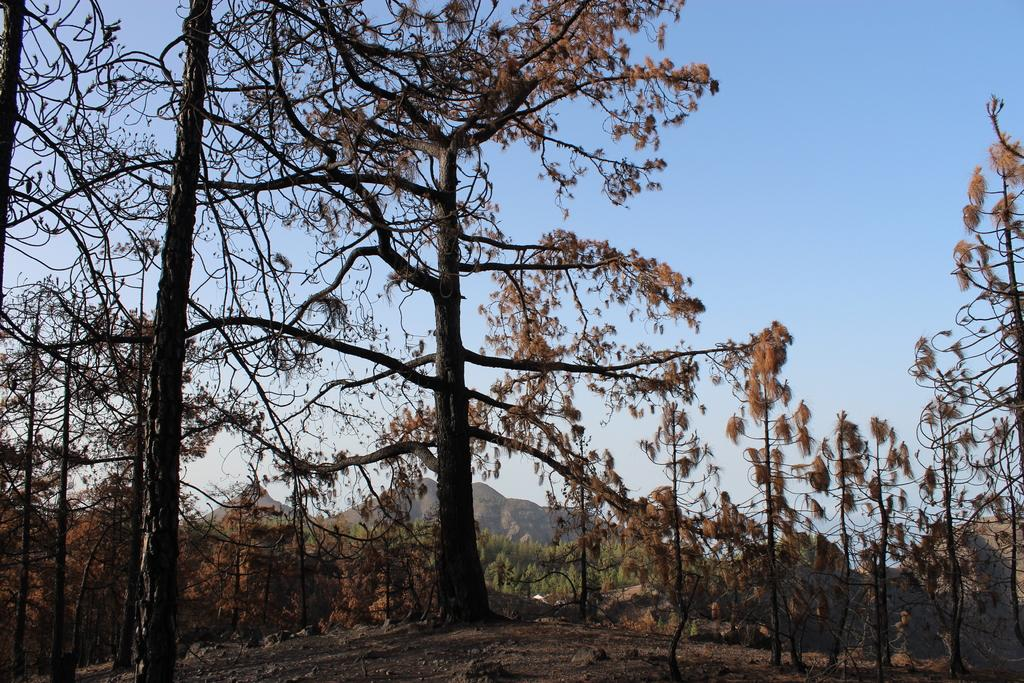What type of vegetation is present in the image? There are trees around the ground in the image. What geographical feature can be seen in the background of the image? There is a mountain visible in the background of the image. What type of oil is being used to comb the trees in the image? There is no oil or combing of trees present in the image; it features trees and a mountain in the background. What statement is being made by the trees in the image? There is no statement being made by the trees in the image; they are simply depicted as part of the natural landscape. 